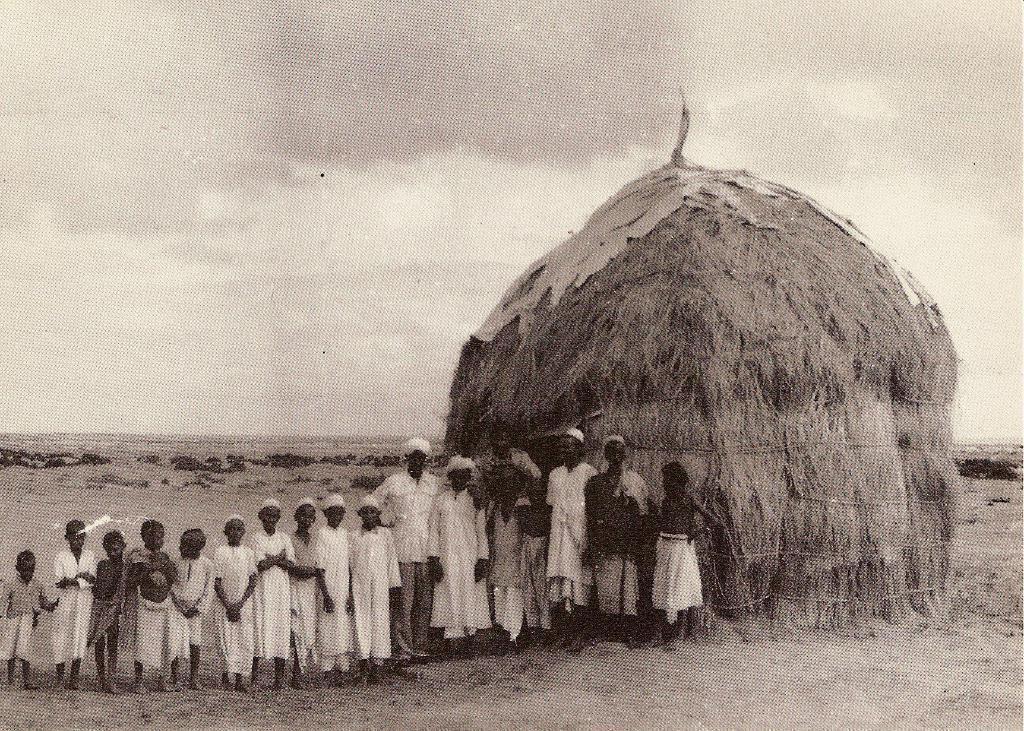What is present in the image that is used for animal bedding or feeding? There is hay in the image, which is commonly used for animal bedding or feeding. Who or what is near the hay in the image? There are people standing near the hay in the image. What type of landscape surrounds the hay and people in the image? The area around the hay and people is plain land. How many twigs are being used to ask questions in the image? There are no twigs present in the image, and they cannot be used to ask questions. 